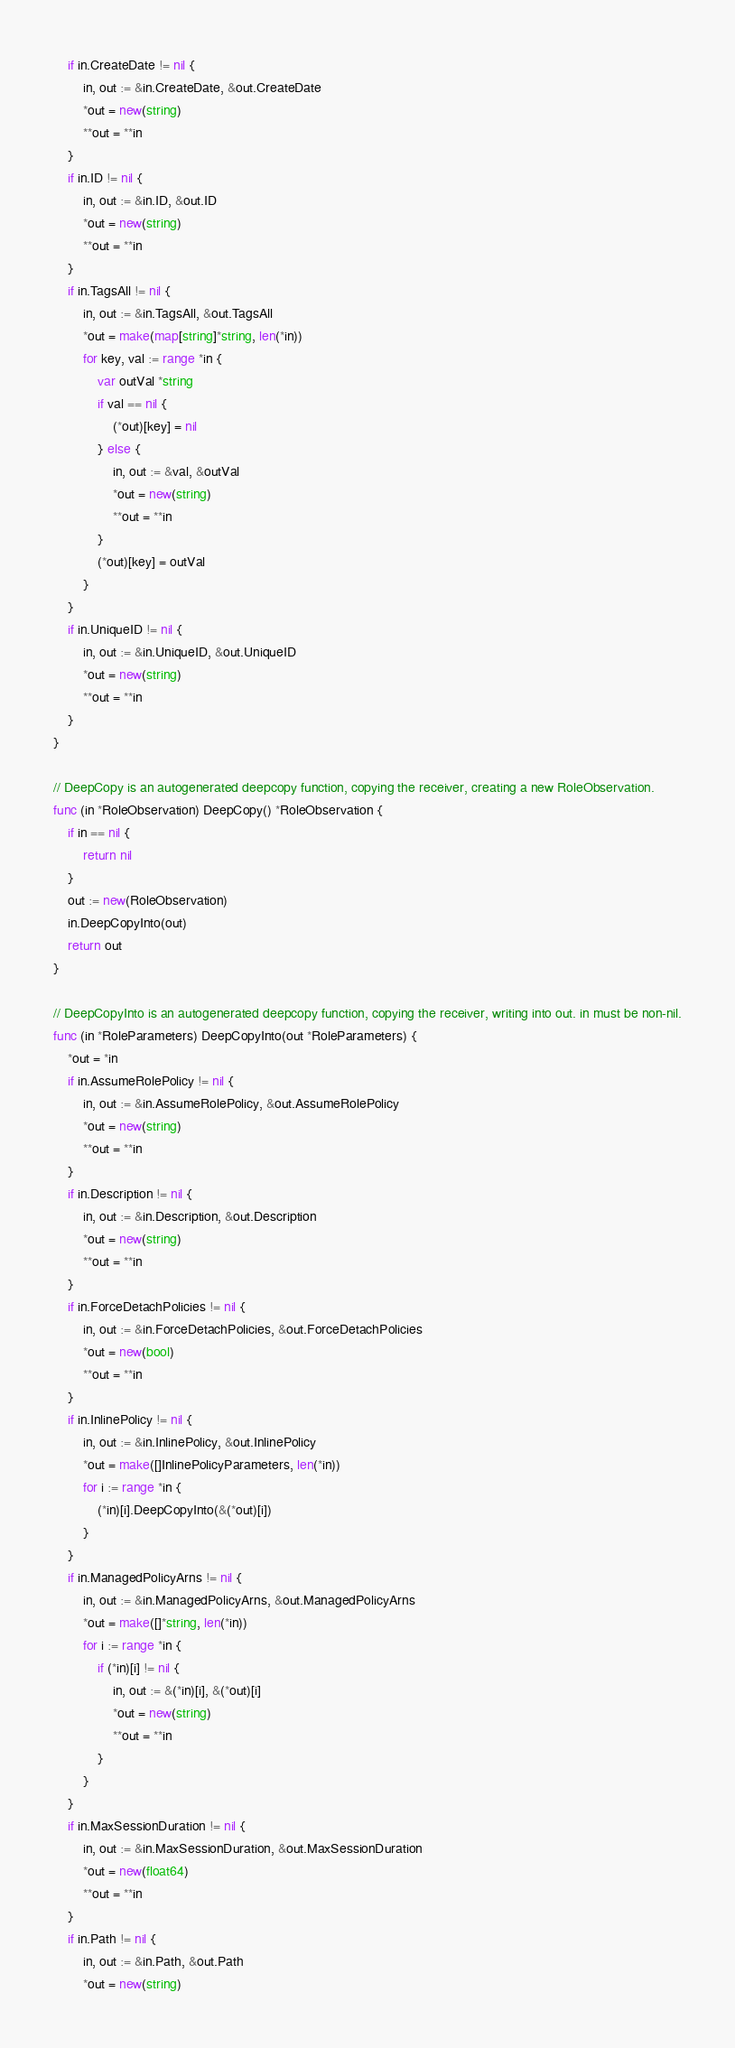Convert code to text. <code><loc_0><loc_0><loc_500><loc_500><_Go_>	if in.CreateDate != nil {
		in, out := &in.CreateDate, &out.CreateDate
		*out = new(string)
		**out = **in
	}
	if in.ID != nil {
		in, out := &in.ID, &out.ID
		*out = new(string)
		**out = **in
	}
	if in.TagsAll != nil {
		in, out := &in.TagsAll, &out.TagsAll
		*out = make(map[string]*string, len(*in))
		for key, val := range *in {
			var outVal *string
			if val == nil {
				(*out)[key] = nil
			} else {
				in, out := &val, &outVal
				*out = new(string)
				**out = **in
			}
			(*out)[key] = outVal
		}
	}
	if in.UniqueID != nil {
		in, out := &in.UniqueID, &out.UniqueID
		*out = new(string)
		**out = **in
	}
}

// DeepCopy is an autogenerated deepcopy function, copying the receiver, creating a new RoleObservation.
func (in *RoleObservation) DeepCopy() *RoleObservation {
	if in == nil {
		return nil
	}
	out := new(RoleObservation)
	in.DeepCopyInto(out)
	return out
}

// DeepCopyInto is an autogenerated deepcopy function, copying the receiver, writing into out. in must be non-nil.
func (in *RoleParameters) DeepCopyInto(out *RoleParameters) {
	*out = *in
	if in.AssumeRolePolicy != nil {
		in, out := &in.AssumeRolePolicy, &out.AssumeRolePolicy
		*out = new(string)
		**out = **in
	}
	if in.Description != nil {
		in, out := &in.Description, &out.Description
		*out = new(string)
		**out = **in
	}
	if in.ForceDetachPolicies != nil {
		in, out := &in.ForceDetachPolicies, &out.ForceDetachPolicies
		*out = new(bool)
		**out = **in
	}
	if in.InlinePolicy != nil {
		in, out := &in.InlinePolicy, &out.InlinePolicy
		*out = make([]InlinePolicyParameters, len(*in))
		for i := range *in {
			(*in)[i].DeepCopyInto(&(*out)[i])
		}
	}
	if in.ManagedPolicyArns != nil {
		in, out := &in.ManagedPolicyArns, &out.ManagedPolicyArns
		*out = make([]*string, len(*in))
		for i := range *in {
			if (*in)[i] != nil {
				in, out := &(*in)[i], &(*out)[i]
				*out = new(string)
				**out = **in
			}
		}
	}
	if in.MaxSessionDuration != nil {
		in, out := &in.MaxSessionDuration, &out.MaxSessionDuration
		*out = new(float64)
		**out = **in
	}
	if in.Path != nil {
		in, out := &in.Path, &out.Path
		*out = new(string)</code> 